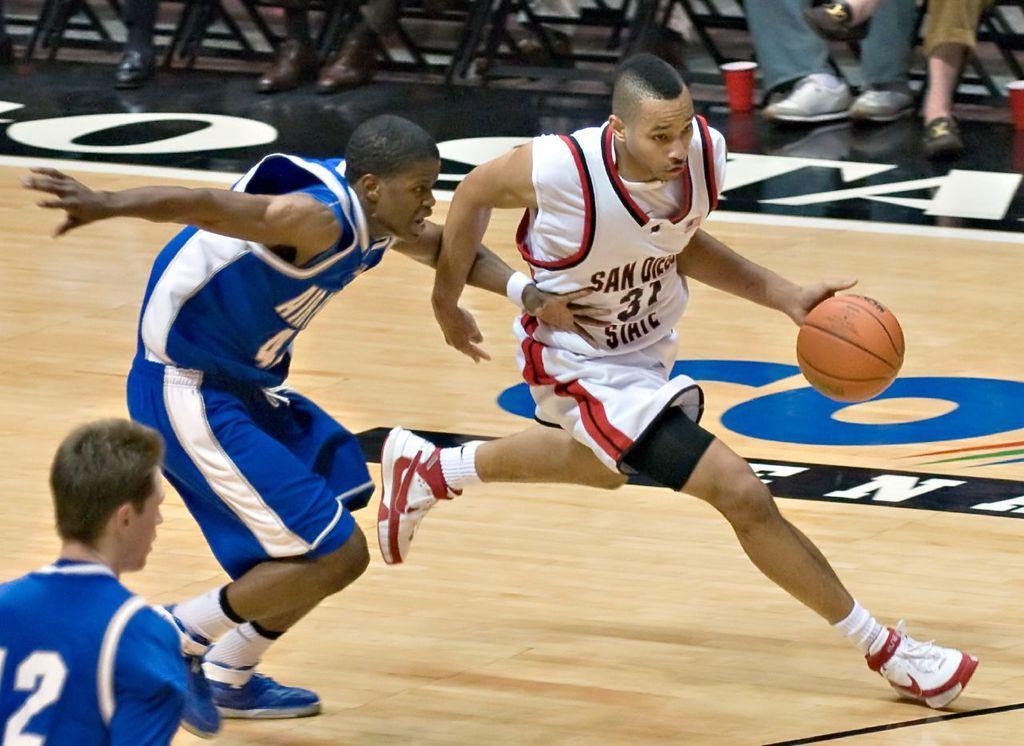Describe this image in one or two sentences. At the left corner of the image there is a man with a blue dress. In front of him there is a man with blue dress is running on the floor. Beside him there is a man with white dress is running on the floor and holding the ball in his hand. At the top of the image there are few chairs, legs of the humans and also there are red color glass on the floor. 